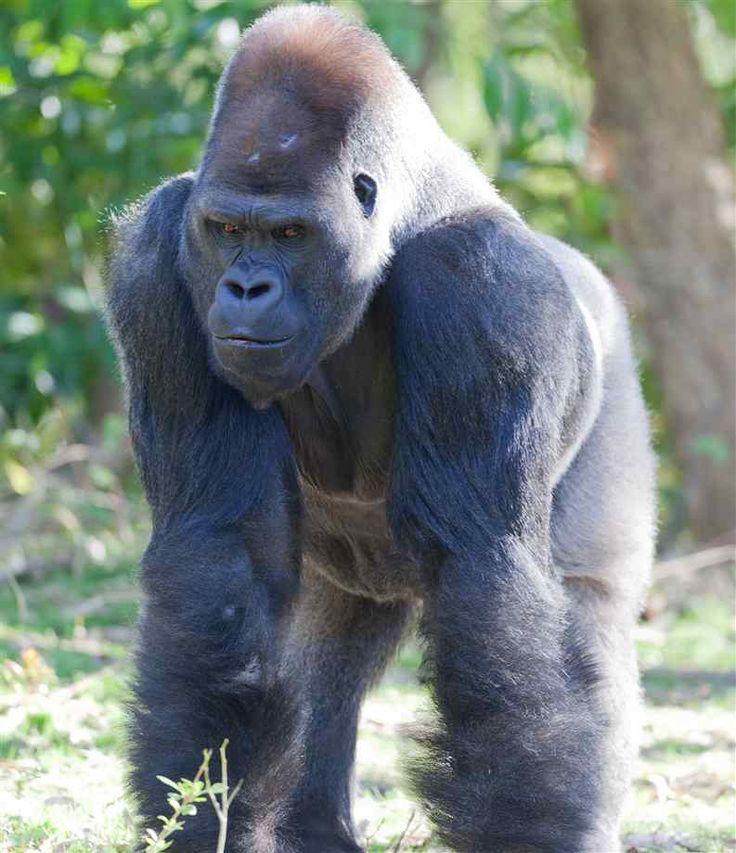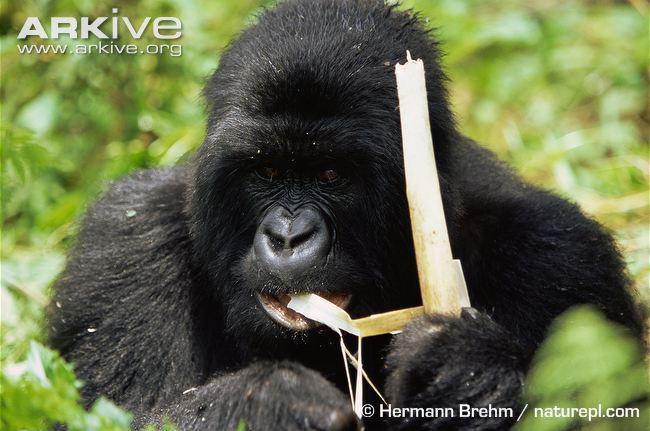The first image is the image on the left, the second image is the image on the right. Given the left and right images, does the statement "A large gorilla is on all fours in one of the images." hold true? Answer yes or no. Yes. 